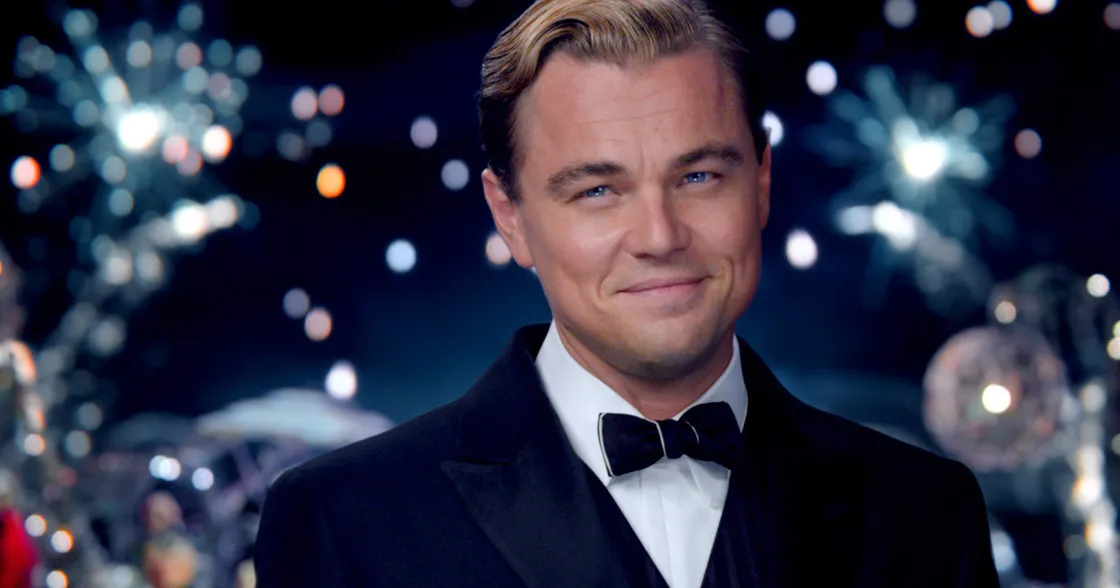What is the significance of the setting behind the character in the image? The backdrop in the image, adorned with vibrant fireworks and party lights, creates a festive and celebratory atmosphere, which could symbolize a grand occasion or event. This setting enhances the character's aura of elegance and charm, suggesting that he is either the host or an important guest at this opulent gathering. How does the background contribute to the character's personality or story? The lavish setting behind the character, including the spectacular fireworks and twinkling lights, contributes significantly to his persona. It implies that he is someone who is accustomed to luxury and grandiose celebrations. The setting suggests a narrative of wealth and power, highlighting the character's sophistication, social status, and possibly a penchant for throwing or attending extravagant parties. Can you describe a possible scenario that could be happening during this moment in the image, both short and long descriptions? Short Description: The character might be enjoying a high-society New Year's Eve party, surrounded by influential guests and breathtaking fireworks, capturing a moment of sheer joy and celebration. Long Description: In the midst of a lavish New Year's Eve party, the character could be playing the role of a gracious host, mingling with elite guests and ensuring everyone is having a splendid time. The night sky is illuminated with spectacular fireworks, reflecting off the character's tuxedo, adding to the night's enchantment. Laughter and music echo in the background, signifying a successful and joyous celebration that marks the beginning of a prosperous year. Imagine an extremely creative scenario involving this character and the festive setting. In a fantastical twist, the character could be an immortal guardian of celebrations, entrusted with the duty to ensure that the world's most significant parties are unforgettable. On this particular night, he conjures the most spectacular fireworks and magical lights, enchanting the air with a sense of wonder and euphoria. With a wave of his hand, he can turn the ordinary into the extraordinary, crafting moments of pure joy and connection among the guests, each of whom leaves with memories that shine like the fireworks in the night sky. Unbeknownst to them, the guardian has been celebrating humanity's joy for centuries, ensuring that the spirit of celebration and camaraderie never fades from the world. 